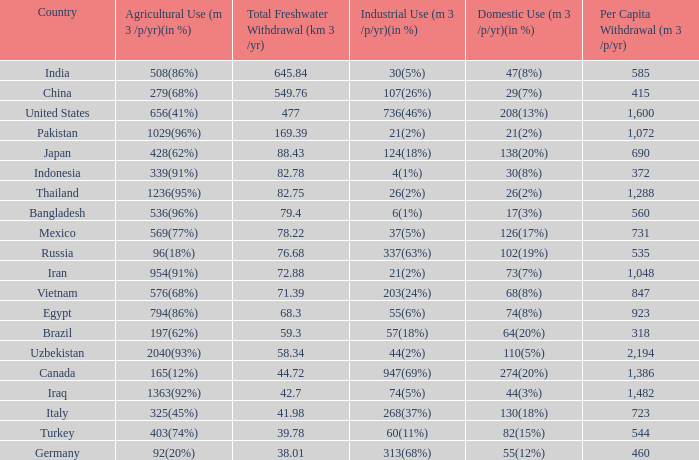What is the average Total Freshwater Withdrawal (km 3 /yr), when Industrial Use (m 3 /p/yr)(in %) is 337(63%), and when Per Capita Withdrawal (m 3 /p/yr) is greater than 535? None. 